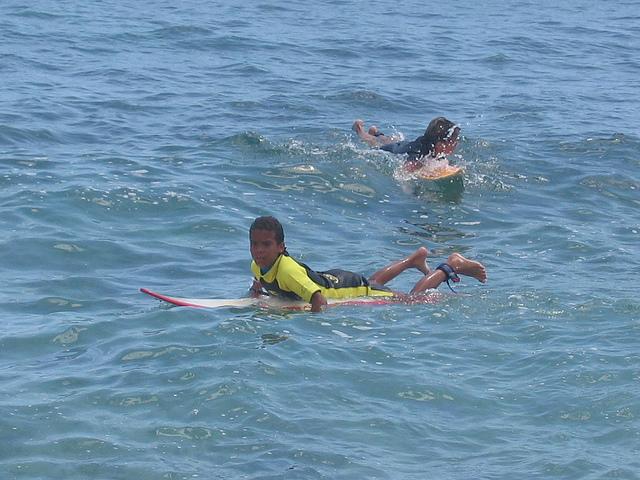What is this kid swimming on?
Quick response, please. Surfboard. Is it night time on the picture?
Keep it brief. No. How does the child keep from losing his board?
Keep it brief. Ankle strap. How many people are in the photo?
Be succinct. 2. 